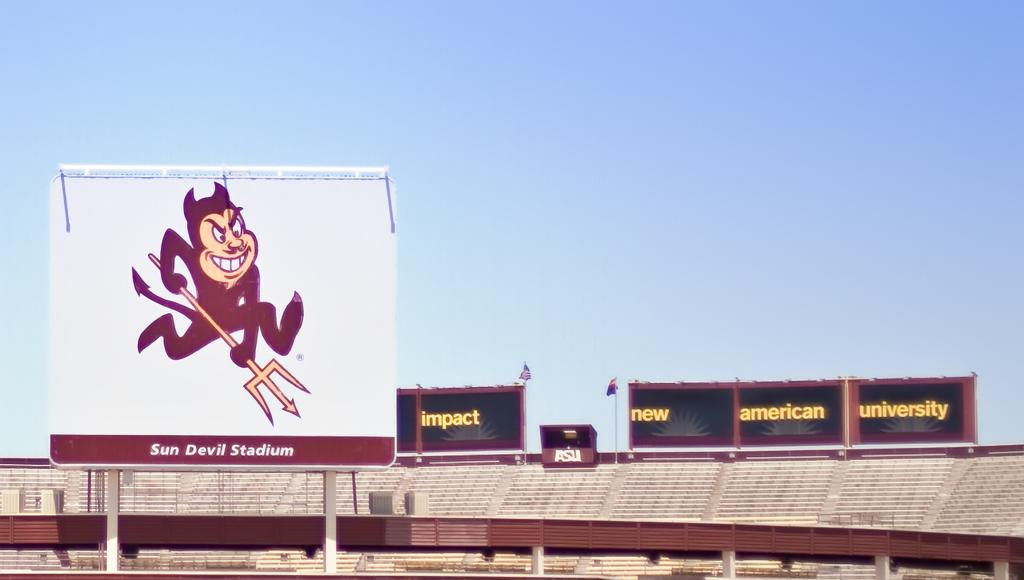<image>
Describe the image concisely. The sun devil Stadium has no people on the stands on a sunny day 